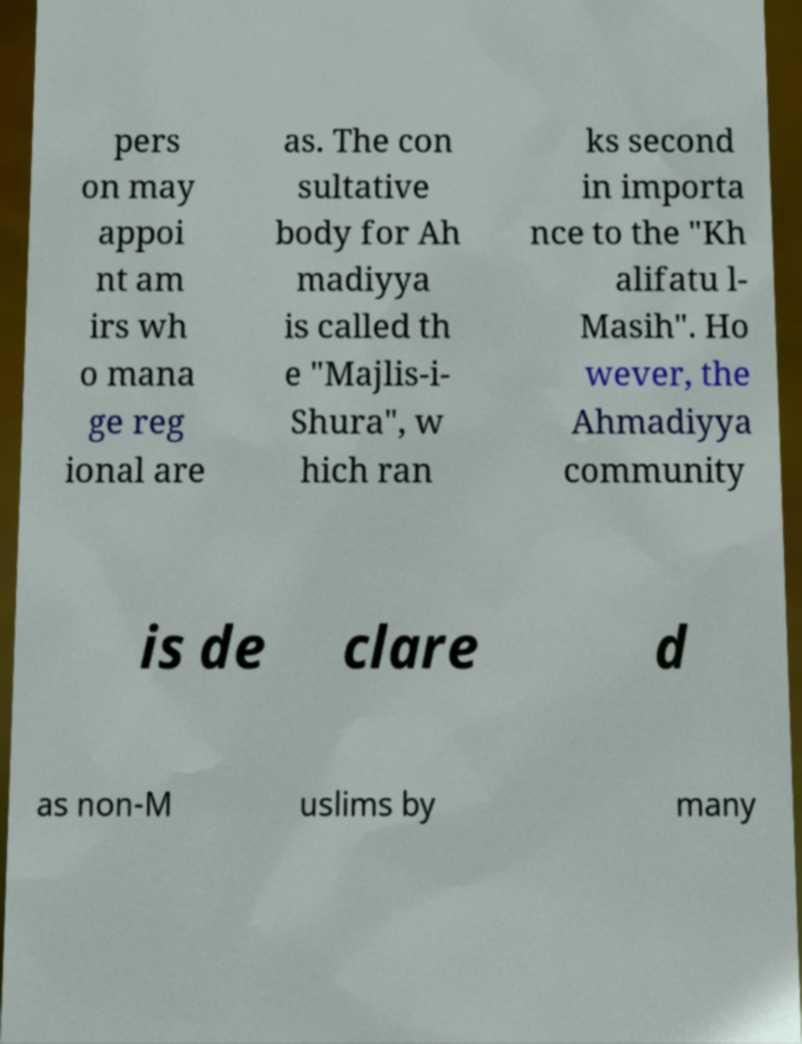Can you read and provide the text displayed in the image?This photo seems to have some interesting text. Can you extract and type it out for me? pers on may appoi nt am irs wh o mana ge reg ional are as. The con sultative body for Ah madiyya is called th e "Majlis-i- Shura", w hich ran ks second in importa nce to the "Kh alifatu l- Masih". Ho wever, the Ahmadiyya community is de clare d as non-M uslims by many 